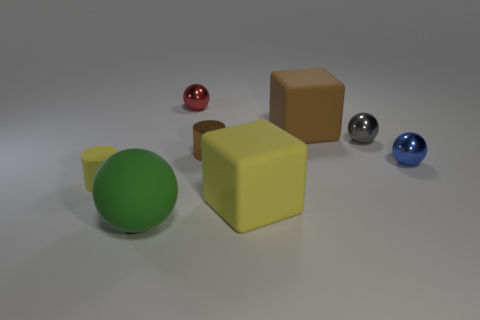What materials do the objects in the image look like they are made of? The objects appear to be rendered with materials that mimic real-world substances. The spheres have a reflective surface suggesting they could be made of polished metal or glass, while the cubes seem to have a matte finish, resembling a plastic or painted wood texture. 